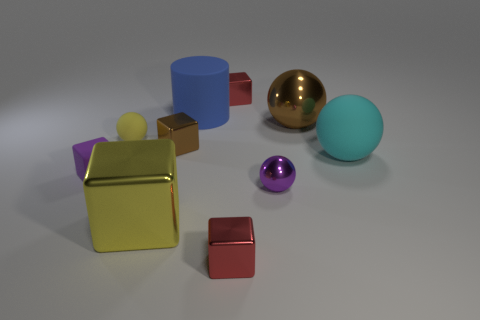What can you infer about the texture of the objects and the light source in the scene? Observing the objects, it is evident that they exhibit varying textures. The blue cylinder and the light blue sphere have a rubber-like finish with a diffuse reflection, indicating a matte or non-reflective texture. The yellow cube also has a matte finish but is more vivid in color. In contrast, the large metallic sphere and the small purple sphere display glossy textures with clear reflections and highlights, suggesting a smooth and reflective surface. As for the light source, the consistent highlights and shadows on the objects suggest that it's coming from the upper left side of the scene, providing soft, ambient illumination and a gentle reflection on the surfaces. 